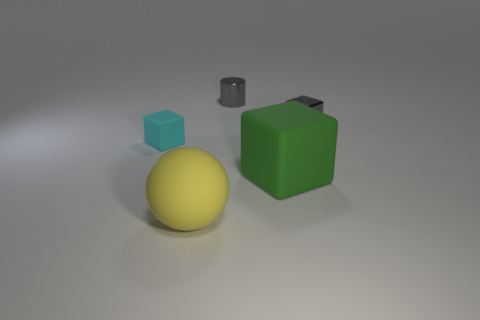There is a tiny metallic object that is right of the gray object that is left of the tiny block that is right of the cyan matte object; what color is it? gray 